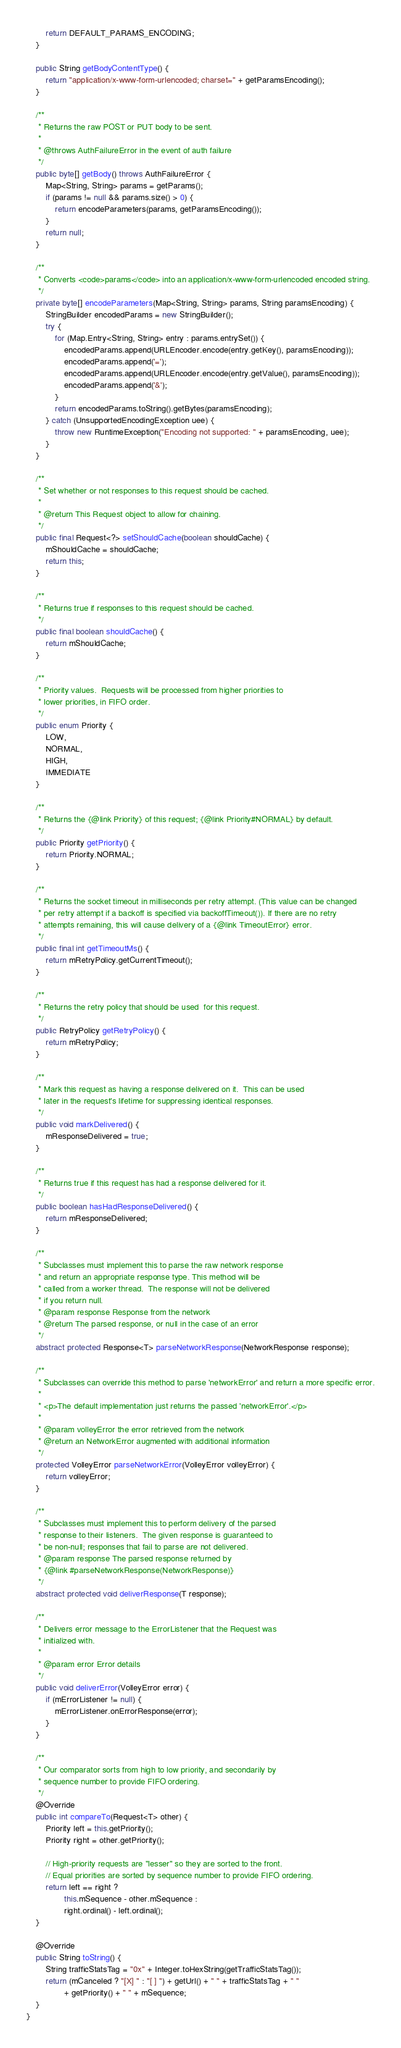Convert code to text. <code><loc_0><loc_0><loc_500><loc_500><_Java_>        return DEFAULT_PARAMS_ENCODING;
    }

    public String getBodyContentType() {
        return "application/x-www-form-urlencoded; charset=" + getParamsEncoding();
    }

    /**
     * Returns the raw POST or PUT body to be sent.
     *
     * @throws AuthFailureError in the event of auth failure
     */
    public byte[] getBody() throws AuthFailureError {
        Map<String, String> params = getParams();
        if (params != null && params.size() > 0) {
            return encodeParameters(params, getParamsEncoding());
        }
        return null;
    }

    /**
     * Converts <code>params</code> into an application/x-www-form-urlencoded encoded string.
     */
    private byte[] encodeParameters(Map<String, String> params, String paramsEncoding) {
        StringBuilder encodedParams = new StringBuilder();
        try {
            for (Map.Entry<String, String> entry : params.entrySet()) {
                encodedParams.append(URLEncoder.encode(entry.getKey(), paramsEncoding));
                encodedParams.append('=');
                encodedParams.append(URLEncoder.encode(entry.getValue(), paramsEncoding));
                encodedParams.append('&');
            }
            return encodedParams.toString().getBytes(paramsEncoding);
        } catch (UnsupportedEncodingException uee) {
            throw new RuntimeException("Encoding not supported: " + paramsEncoding, uee);
        }
    }

    /**
     * Set whether or not responses to this request should be cached.
     *
     * @return This Request object to allow for chaining.
     */
    public final Request<?> setShouldCache(boolean shouldCache) {
        mShouldCache = shouldCache;
        return this;
    }

    /**
     * Returns true if responses to this request should be cached.
     */
    public final boolean shouldCache() {
        return mShouldCache;
    }

    /**
     * Priority values.  Requests will be processed from higher priorities to
     * lower priorities, in FIFO order.
     */
    public enum Priority {
        LOW,
        NORMAL,
        HIGH,
        IMMEDIATE
    }

    /**
     * Returns the {@link Priority} of this request; {@link Priority#NORMAL} by default.
     */
    public Priority getPriority() {
        return Priority.NORMAL;
    }

    /**
     * Returns the socket timeout in milliseconds per retry attempt. (This value can be changed
     * per retry attempt if a backoff is specified via backoffTimeout()). If there are no retry
     * attempts remaining, this will cause delivery of a {@link TimeoutError} error.
     */
    public final int getTimeoutMs() {
        return mRetryPolicy.getCurrentTimeout();
    }

    /**
     * Returns the retry policy that should be used  for this request.
     */
    public RetryPolicy getRetryPolicy() {
        return mRetryPolicy;
    }

    /**
     * Mark this request as having a response delivered on it.  This can be used
     * later in the request's lifetime for suppressing identical responses.
     */
    public void markDelivered() {
        mResponseDelivered = true;
    }

    /**
     * Returns true if this request has had a response delivered for it.
     */
    public boolean hasHadResponseDelivered() {
        return mResponseDelivered;
    }

    /**
     * Subclasses must implement this to parse the raw network response
     * and return an appropriate response type. This method will be
     * called from a worker thread.  The response will not be delivered
     * if you return null.
     * @param response Response from the network
     * @return The parsed response, or null in the case of an error
     */
    abstract protected Response<T> parseNetworkResponse(NetworkResponse response);

    /**
     * Subclasses can override this method to parse 'networkError' and return a more specific error.
     *
     * <p>The default implementation just returns the passed 'networkError'.</p>
     *
     * @param volleyError the error retrieved from the network
     * @return an NetworkError augmented with additional information
     */
    protected VolleyError parseNetworkError(VolleyError volleyError) {
        return volleyError;
    }

    /**
     * Subclasses must implement this to perform delivery of the parsed
     * response to their listeners.  The given response is guaranteed to
     * be non-null; responses that fail to parse are not delivered.
     * @param response The parsed response returned by
     * {@link #parseNetworkResponse(NetworkResponse)}
     */
    abstract protected void deliverResponse(T response);

    /**
     * Delivers error message to the ErrorListener that the Request was
     * initialized with.
     *
     * @param error Error details
     */
    public void deliverError(VolleyError error) {
        if (mErrorListener != null) {
            mErrorListener.onErrorResponse(error);
        }
    }

    /**
     * Our comparator sorts from high to low priority, and secondarily by
     * sequence number to provide FIFO ordering.
     */
    @Override
    public int compareTo(Request<T> other) {
        Priority left = this.getPriority();
        Priority right = other.getPriority();

        // High-priority requests are "lesser" so they are sorted to the front.
        // Equal priorities are sorted by sequence number to provide FIFO ordering.
        return left == right ?
                this.mSequence - other.mSequence :
                right.ordinal() - left.ordinal();
    }

    @Override
    public String toString() {
        String trafficStatsTag = "0x" + Integer.toHexString(getTrafficStatsTag());
        return (mCanceled ? "[X] " : "[ ] ") + getUrl() + " " + trafficStatsTag + " "
                + getPriority() + " " + mSequence;
    }
}
</code> 